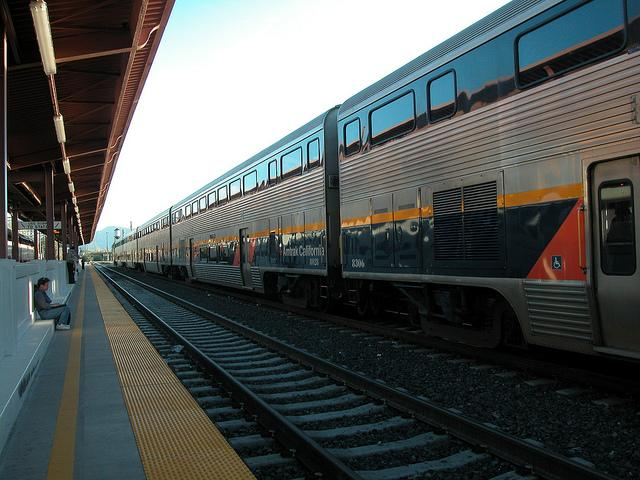What color is the triangle halves on the side of the bus next to the luggage holders? Please explain your reasoning. orange. The triangle is not black, yellow, or green. 